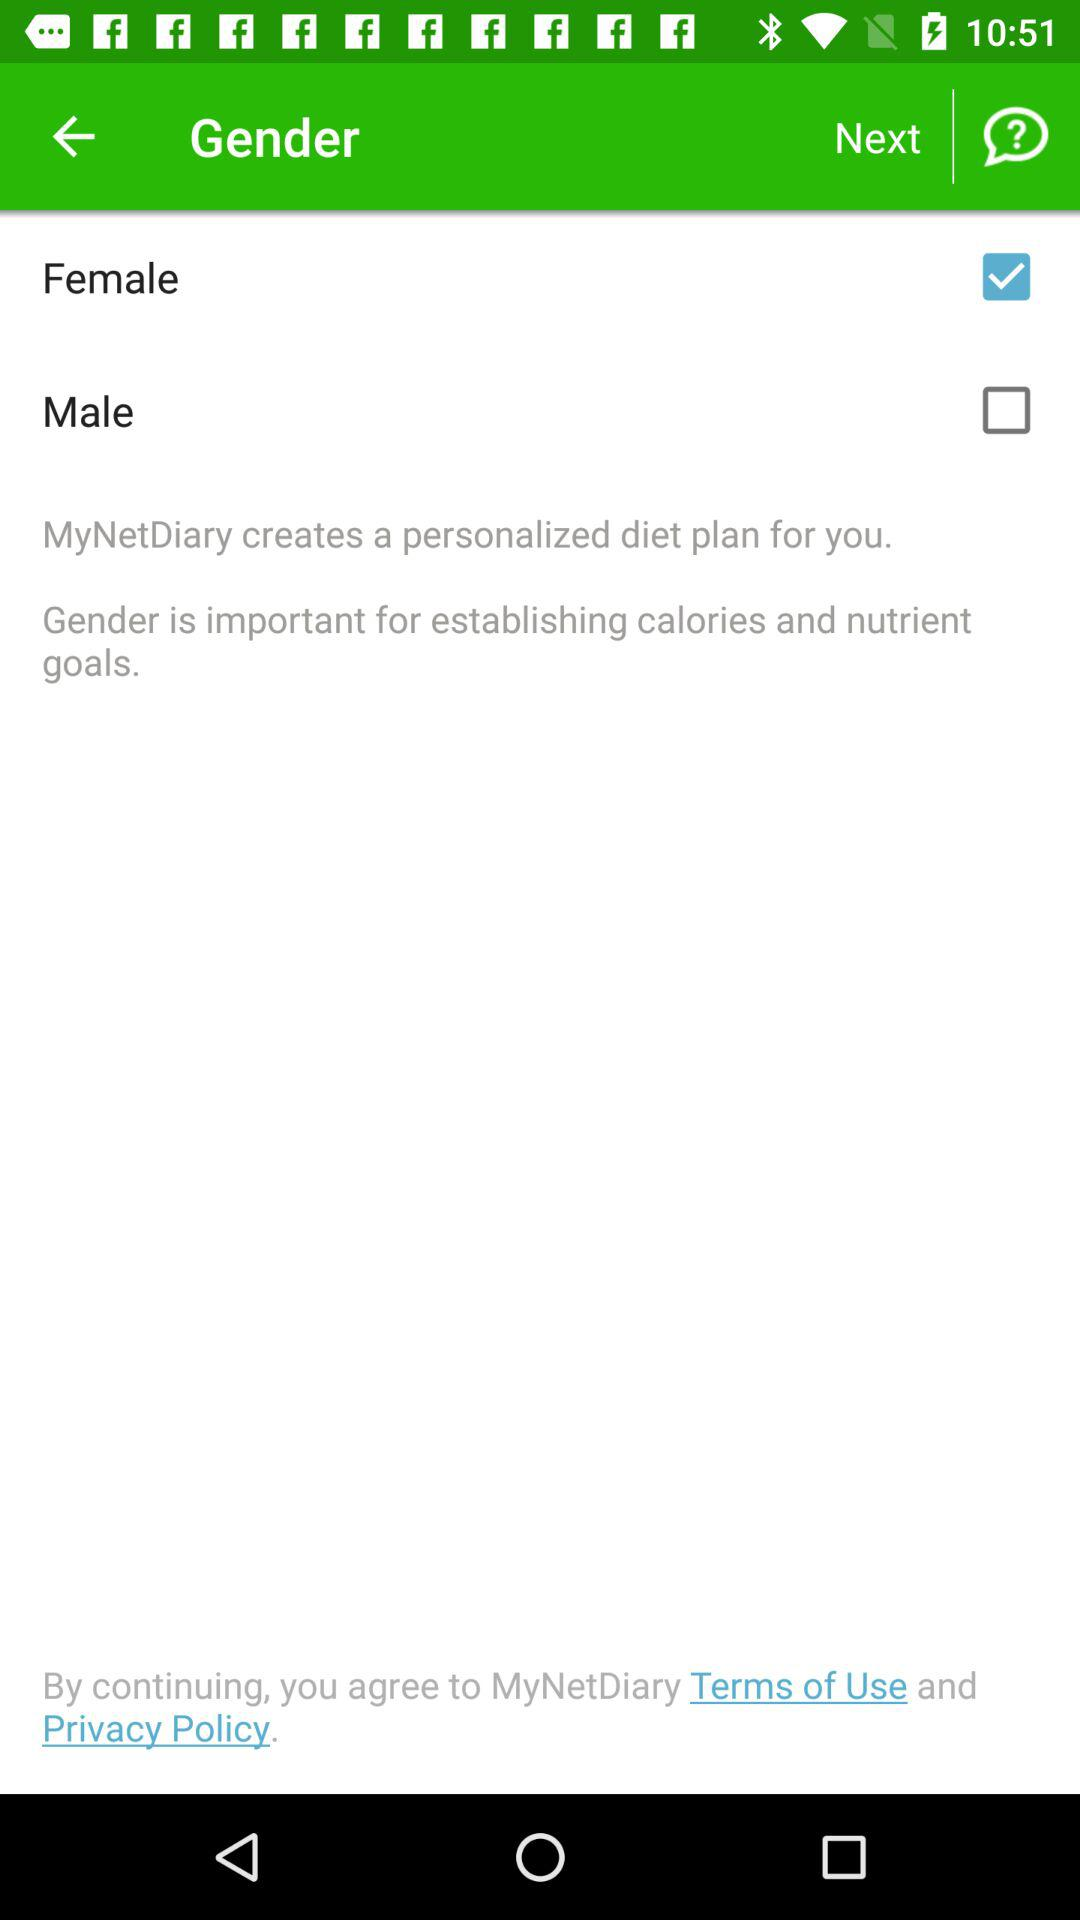What is the application name? The application name is "MyNetDiary". 